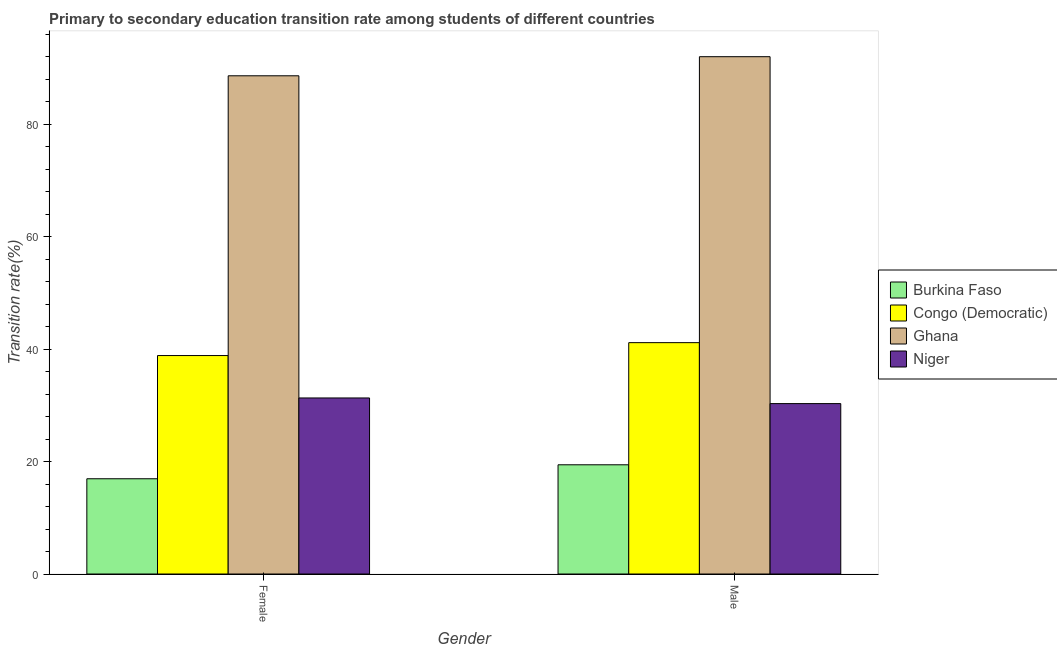Are the number of bars on each tick of the X-axis equal?
Your response must be concise. Yes. What is the label of the 2nd group of bars from the left?
Your response must be concise. Male. What is the transition rate among male students in Burkina Faso?
Ensure brevity in your answer.  19.43. Across all countries, what is the maximum transition rate among male students?
Offer a very short reply. 92.01. Across all countries, what is the minimum transition rate among female students?
Your answer should be compact. 16.94. In which country was the transition rate among female students maximum?
Offer a terse response. Ghana. In which country was the transition rate among male students minimum?
Your answer should be very brief. Burkina Faso. What is the total transition rate among female students in the graph?
Give a very brief answer. 175.72. What is the difference between the transition rate among male students in Congo (Democratic) and that in Burkina Faso?
Your answer should be very brief. 21.72. What is the difference between the transition rate among male students in Burkina Faso and the transition rate among female students in Ghana?
Provide a succinct answer. -69.19. What is the average transition rate among female students per country?
Keep it short and to the point. 43.93. What is the difference between the transition rate among female students and transition rate among male students in Niger?
Provide a succinct answer. 1. What is the ratio of the transition rate among male students in Burkina Faso to that in Congo (Democratic)?
Give a very brief answer. 0.47. Is the transition rate among female students in Niger less than that in Ghana?
Offer a terse response. Yes. What does the 1st bar from the right in Male represents?
Keep it short and to the point. Niger. How many countries are there in the graph?
Provide a short and direct response. 4. Are the values on the major ticks of Y-axis written in scientific E-notation?
Offer a terse response. No. Where does the legend appear in the graph?
Ensure brevity in your answer.  Center right. How many legend labels are there?
Offer a terse response. 4. How are the legend labels stacked?
Your answer should be compact. Vertical. What is the title of the graph?
Offer a very short reply. Primary to secondary education transition rate among students of different countries. What is the label or title of the Y-axis?
Provide a short and direct response. Transition rate(%). What is the Transition rate(%) in Burkina Faso in Female?
Provide a short and direct response. 16.94. What is the Transition rate(%) in Congo (Democratic) in Female?
Your answer should be very brief. 38.85. What is the Transition rate(%) of Ghana in Female?
Provide a succinct answer. 88.61. What is the Transition rate(%) in Niger in Female?
Offer a very short reply. 31.31. What is the Transition rate(%) in Burkina Faso in Male?
Offer a very short reply. 19.43. What is the Transition rate(%) in Congo (Democratic) in Male?
Offer a very short reply. 41.15. What is the Transition rate(%) in Ghana in Male?
Keep it short and to the point. 92.01. What is the Transition rate(%) in Niger in Male?
Give a very brief answer. 30.31. Across all Gender, what is the maximum Transition rate(%) in Burkina Faso?
Make the answer very short. 19.43. Across all Gender, what is the maximum Transition rate(%) in Congo (Democratic)?
Give a very brief answer. 41.15. Across all Gender, what is the maximum Transition rate(%) in Ghana?
Give a very brief answer. 92.01. Across all Gender, what is the maximum Transition rate(%) in Niger?
Keep it short and to the point. 31.31. Across all Gender, what is the minimum Transition rate(%) of Burkina Faso?
Keep it short and to the point. 16.94. Across all Gender, what is the minimum Transition rate(%) of Congo (Democratic)?
Make the answer very short. 38.85. Across all Gender, what is the minimum Transition rate(%) in Ghana?
Offer a very short reply. 88.61. Across all Gender, what is the minimum Transition rate(%) of Niger?
Provide a short and direct response. 30.31. What is the total Transition rate(%) in Burkina Faso in the graph?
Offer a very short reply. 36.37. What is the total Transition rate(%) in Congo (Democratic) in the graph?
Keep it short and to the point. 80. What is the total Transition rate(%) of Ghana in the graph?
Your answer should be very brief. 180.62. What is the total Transition rate(%) of Niger in the graph?
Offer a terse response. 61.62. What is the difference between the Transition rate(%) in Burkina Faso in Female and that in Male?
Your response must be concise. -2.48. What is the difference between the Transition rate(%) in Congo (Democratic) in Female and that in Male?
Ensure brevity in your answer.  -2.29. What is the difference between the Transition rate(%) in Ghana in Female and that in Male?
Your response must be concise. -3.4. What is the difference between the Transition rate(%) in Niger in Female and that in Male?
Offer a very short reply. 1. What is the difference between the Transition rate(%) of Burkina Faso in Female and the Transition rate(%) of Congo (Democratic) in Male?
Provide a succinct answer. -24.21. What is the difference between the Transition rate(%) of Burkina Faso in Female and the Transition rate(%) of Ghana in Male?
Offer a terse response. -75.07. What is the difference between the Transition rate(%) of Burkina Faso in Female and the Transition rate(%) of Niger in Male?
Offer a very short reply. -13.37. What is the difference between the Transition rate(%) of Congo (Democratic) in Female and the Transition rate(%) of Ghana in Male?
Offer a very short reply. -53.16. What is the difference between the Transition rate(%) in Congo (Democratic) in Female and the Transition rate(%) in Niger in Male?
Your answer should be compact. 8.55. What is the difference between the Transition rate(%) in Ghana in Female and the Transition rate(%) in Niger in Male?
Offer a terse response. 58.3. What is the average Transition rate(%) of Burkina Faso per Gender?
Give a very brief answer. 18.18. What is the average Transition rate(%) of Congo (Democratic) per Gender?
Keep it short and to the point. 40. What is the average Transition rate(%) in Ghana per Gender?
Your answer should be very brief. 90.31. What is the average Transition rate(%) of Niger per Gender?
Offer a terse response. 30.81. What is the difference between the Transition rate(%) in Burkina Faso and Transition rate(%) in Congo (Democratic) in Female?
Ensure brevity in your answer.  -21.91. What is the difference between the Transition rate(%) in Burkina Faso and Transition rate(%) in Ghana in Female?
Make the answer very short. -71.67. What is the difference between the Transition rate(%) of Burkina Faso and Transition rate(%) of Niger in Female?
Your answer should be compact. -14.37. What is the difference between the Transition rate(%) in Congo (Democratic) and Transition rate(%) in Ghana in Female?
Give a very brief answer. -49.76. What is the difference between the Transition rate(%) of Congo (Democratic) and Transition rate(%) of Niger in Female?
Provide a short and direct response. 7.54. What is the difference between the Transition rate(%) of Ghana and Transition rate(%) of Niger in Female?
Offer a very short reply. 57.3. What is the difference between the Transition rate(%) in Burkina Faso and Transition rate(%) in Congo (Democratic) in Male?
Give a very brief answer. -21.72. What is the difference between the Transition rate(%) of Burkina Faso and Transition rate(%) of Ghana in Male?
Offer a terse response. -72.58. What is the difference between the Transition rate(%) in Burkina Faso and Transition rate(%) in Niger in Male?
Offer a very short reply. -10.88. What is the difference between the Transition rate(%) of Congo (Democratic) and Transition rate(%) of Ghana in Male?
Provide a short and direct response. -50.86. What is the difference between the Transition rate(%) in Congo (Democratic) and Transition rate(%) in Niger in Male?
Offer a terse response. 10.84. What is the difference between the Transition rate(%) in Ghana and Transition rate(%) in Niger in Male?
Offer a very short reply. 61.7. What is the ratio of the Transition rate(%) of Burkina Faso in Female to that in Male?
Ensure brevity in your answer.  0.87. What is the ratio of the Transition rate(%) of Congo (Democratic) in Female to that in Male?
Your answer should be very brief. 0.94. What is the ratio of the Transition rate(%) in Ghana in Female to that in Male?
Your response must be concise. 0.96. What is the ratio of the Transition rate(%) of Niger in Female to that in Male?
Keep it short and to the point. 1.03. What is the difference between the highest and the second highest Transition rate(%) in Burkina Faso?
Make the answer very short. 2.48. What is the difference between the highest and the second highest Transition rate(%) of Congo (Democratic)?
Provide a succinct answer. 2.29. What is the difference between the highest and the second highest Transition rate(%) of Ghana?
Give a very brief answer. 3.4. What is the difference between the highest and the lowest Transition rate(%) of Burkina Faso?
Provide a succinct answer. 2.48. What is the difference between the highest and the lowest Transition rate(%) in Congo (Democratic)?
Your answer should be very brief. 2.29. What is the difference between the highest and the lowest Transition rate(%) in Ghana?
Your answer should be very brief. 3.4. 